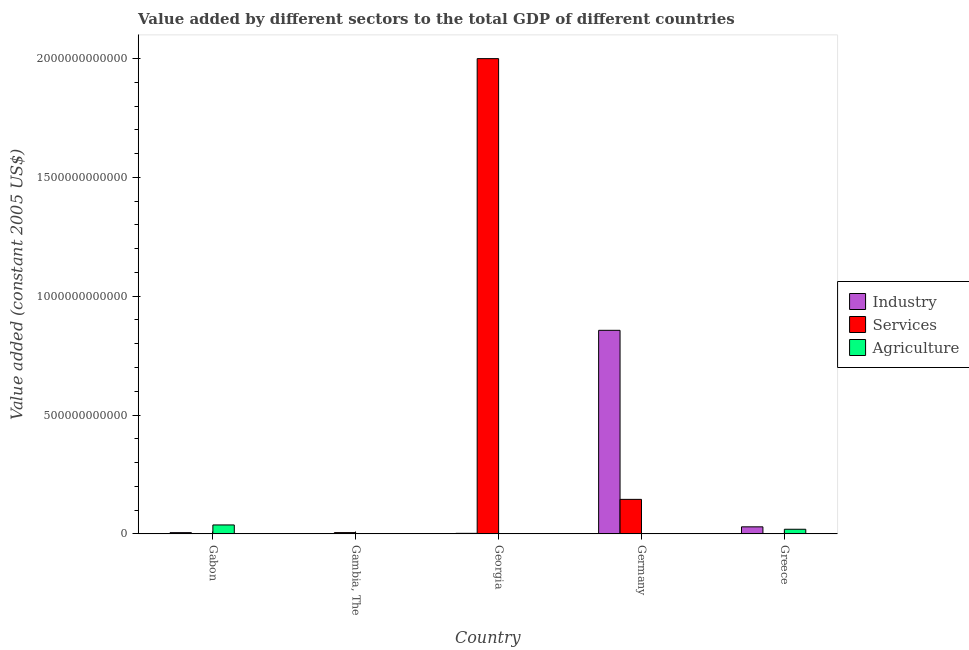How many groups of bars are there?
Your answer should be compact. 5. Are the number of bars per tick equal to the number of legend labels?
Offer a very short reply. Yes. Are the number of bars on each tick of the X-axis equal?
Ensure brevity in your answer.  Yes. How many bars are there on the 5th tick from the left?
Give a very brief answer. 3. What is the label of the 5th group of bars from the left?
Make the answer very short. Greece. In how many cases, is the number of bars for a given country not equal to the number of legend labels?
Give a very brief answer. 0. What is the value added by services in Greece?
Offer a terse response. 4.62e+08. Across all countries, what is the maximum value added by industrial sector?
Your response must be concise. 8.56e+11. Across all countries, what is the minimum value added by services?
Provide a succinct answer. 4.58e+08. In which country was the value added by industrial sector maximum?
Your answer should be compact. Germany. In which country was the value added by industrial sector minimum?
Provide a succinct answer. Gambia, The. What is the total value added by agricultural sector in the graph?
Offer a terse response. 5.84e+1. What is the difference between the value added by industrial sector in Georgia and that in Greece?
Offer a terse response. -2.74e+1. What is the difference between the value added by agricultural sector in Georgia and the value added by services in Greece?
Your response must be concise. -2.84e+08. What is the average value added by industrial sector per country?
Provide a succinct answer. 1.79e+11. What is the difference between the value added by agricultural sector and value added by industrial sector in Gabon?
Give a very brief answer. 3.23e+1. What is the ratio of the value added by agricultural sector in Gabon to that in Greece?
Your response must be concise. 1.94. Is the difference between the value added by industrial sector in Germany and Greece greater than the difference between the value added by agricultural sector in Germany and Greece?
Offer a very short reply. Yes. What is the difference between the highest and the second highest value added by services?
Provide a succinct answer. 1.85e+12. What is the difference between the highest and the lowest value added by agricultural sector?
Keep it short and to the point. 3.73e+1. In how many countries, is the value added by industrial sector greater than the average value added by industrial sector taken over all countries?
Your answer should be very brief. 1. Is the sum of the value added by services in Gambia, The and Greece greater than the maximum value added by agricultural sector across all countries?
Offer a terse response. No. What does the 3rd bar from the left in Gambia, The represents?
Your answer should be very brief. Agriculture. What does the 3rd bar from the right in Gambia, The represents?
Provide a short and direct response. Industry. Is it the case that in every country, the sum of the value added by industrial sector and value added by services is greater than the value added by agricultural sector?
Provide a succinct answer. No. Are all the bars in the graph horizontal?
Keep it short and to the point. No. How many countries are there in the graph?
Provide a succinct answer. 5. What is the difference between two consecutive major ticks on the Y-axis?
Ensure brevity in your answer.  5.00e+11. Where does the legend appear in the graph?
Your response must be concise. Center right. How many legend labels are there?
Offer a terse response. 3. What is the title of the graph?
Make the answer very short. Value added by different sectors to the total GDP of different countries. What is the label or title of the X-axis?
Your answer should be very brief. Country. What is the label or title of the Y-axis?
Offer a very short reply. Value added (constant 2005 US$). What is the Value added (constant 2005 US$) in Industry in Gabon?
Your answer should be compact. 5.19e+09. What is the Value added (constant 2005 US$) of Services in Gabon?
Give a very brief answer. 4.58e+08. What is the Value added (constant 2005 US$) in Agriculture in Gabon?
Your response must be concise. 3.75e+1. What is the Value added (constant 2005 US$) of Industry in Gambia, The?
Your answer should be compact. 1.10e+08. What is the Value added (constant 2005 US$) of Services in Gambia, The?
Your answer should be compact. 5.32e+09. What is the Value added (constant 2005 US$) of Agriculture in Gambia, The?
Make the answer very short. 4.72e+08. What is the Value added (constant 2005 US$) of Industry in Georgia?
Your answer should be compact. 2.22e+09. What is the Value added (constant 2005 US$) in Services in Georgia?
Offer a terse response. 2.00e+12. What is the Value added (constant 2005 US$) in Agriculture in Georgia?
Keep it short and to the point. 1.79e+08. What is the Value added (constant 2005 US$) in Industry in Germany?
Give a very brief answer. 8.56e+11. What is the Value added (constant 2005 US$) in Services in Germany?
Keep it short and to the point. 1.45e+11. What is the Value added (constant 2005 US$) in Agriculture in Germany?
Make the answer very short. 8.41e+08. What is the Value added (constant 2005 US$) of Industry in Greece?
Provide a succinct answer. 2.96e+1. What is the Value added (constant 2005 US$) in Services in Greece?
Your response must be concise. 4.62e+08. What is the Value added (constant 2005 US$) of Agriculture in Greece?
Your answer should be compact. 1.94e+1. Across all countries, what is the maximum Value added (constant 2005 US$) of Industry?
Provide a short and direct response. 8.56e+11. Across all countries, what is the maximum Value added (constant 2005 US$) in Services?
Your response must be concise. 2.00e+12. Across all countries, what is the maximum Value added (constant 2005 US$) in Agriculture?
Keep it short and to the point. 3.75e+1. Across all countries, what is the minimum Value added (constant 2005 US$) of Industry?
Ensure brevity in your answer.  1.10e+08. Across all countries, what is the minimum Value added (constant 2005 US$) of Services?
Your answer should be compact. 4.58e+08. Across all countries, what is the minimum Value added (constant 2005 US$) of Agriculture?
Provide a short and direct response. 1.79e+08. What is the total Value added (constant 2005 US$) in Industry in the graph?
Provide a short and direct response. 8.93e+11. What is the total Value added (constant 2005 US$) in Services in the graph?
Make the answer very short. 2.15e+12. What is the total Value added (constant 2005 US$) in Agriculture in the graph?
Ensure brevity in your answer.  5.84e+1. What is the difference between the Value added (constant 2005 US$) in Industry in Gabon and that in Gambia, The?
Ensure brevity in your answer.  5.08e+09. What is the difference between the Value added (constant 2005 US$) of Services in Gabon and that in Gambia, The?
Offer a very short reply. -4.87e+09. What is the difference between the Value added (constant 2005 US$) in Agriculture in Gabon and that in Gambia, The?
Your answer should be compact. 3.70e+1. What is the difference between the Value added (constant 2005 US$) of Industry in Gabon and that in Georgia?
Offer a terse response. 2.97e+09. What is the difference between the Value added (constant 2005 US$) of Services in Gabon and that in Georgia?
Offer a terse response. -2.00e+12. What is the difference between the Value added (constant 2005 US$) of Agriculture in Gabon and that in Georgia?
Provide a short and direct response. 3.73e+1. What is the difference between the Value added (constant 2005 US$) of Industry in Gabon and that in Germany?
Your answer should be compact. -8.51e+11. What is the difference between the Value added (constant 2005 US$) in Services in Gabon and that in Germany?
Your answer should be very brief. -1.45e+11. What is the difference between the Value added (constant 2005 US$) of Agriculture in Gabon and that in Germany?
Your response must be concise. 3.67e+1. What is the difference between the Value added (constant 2005 US$) in Industry in Gabon and that in Greece?
Your answer should be very brief. -2.44e+1. What is the difference between the Value added (constant 2005 US$) in Services in Gabon and that in Greece?
Offer a very short reply. -4.77e+06. What is the difference between the Value added (constant 2005 US$) of Agriculture in Gabon and that in Greece?
Provide a succinct answer. 1.82e+1. What is the difference between the Value added (constant 2005 US$) in Industry in Gambia, The and that in Georgia?
Make the answer very short. -2.11e+09. What is the difference between the Value added (constant 2005 US$) of Services in Gambia, The and that in Georgia?
Your answer should be very brief. -1.99e+12. What is the difference between the Value added (constant 2005 US$) of Agriculture in Gambia, The and that in Georgia?
Make the answer very short. 2.93e+08. What is the difference between the Value added (constant 2005 US$) of Industry in Gambia, The and that in Germany?
Provide a succinct answer. -8.56e+11. What is the difference between the Value added (constant 2005 US$) in Services in Gambia, The and that in Germany?
Provide a short and direct response. -1.40e+11. What is the difference between the Value added (constant 2005 US$) in Agriculture in Gambia, The and that in Germany?
Give a very brief answer. -3.69e+08. What is the difference between the Value added (constant 2005 US$) in Industry in Gambia, The and that in Greece?
Offer a terse response. -2.95e+1. What is the difference between the Value added (constant 2005 US$) in Services in Gambia, The and that in Greece?
Your response must be concise. 4.86e+09. What is the difference between the Value added (constant 2005 US$) of Agriculture in Gambia, The and that in Greece?
Ensure brevity in your answer.  -1.89e+1. What is the difference between the Value added (constant 2005 US$) of Industry in Georgia and that in Germany?
Offer a very short reply. -8.54e+11. What is the difference between the Value added (constant 2005 US$) in Services in Georgia and that in Germany?
Ensure brevity in your answer.  1.85e+12. What is the difference between the Value added (constant 2005 US$) in Agriculture in Georgia and that in Germany?
Make the answer very short. -6.62e+08. What is the difference between the Value added (constant 2005 US$) in Industry in Georgia and that in Greece?
Your answer should be very brief. -2.74e+1. What is the difference between the Value added (constant 2005 US$) in Services in Georgia and that in Greece?
Your answer should be very brief. 2.00e+12. What is the difference between the Value added (constant 2005 US$) in Agriculture in Georgia and that in Greece?
Make the answer very short. -1.92e+1. What is the difference between the Value added (constant 2005 US$) in Industry in Germany and that in Greece?
Give a very brief answer. 8.27e+11. What is the difference between the Value added (constant 2005 US$) of Services in Germany and that in Greece?
Provide a short and direct response. 1.45e+11. What is the difference between the Value added (constant 2005 US$) of Agriculture in Germany and that in Greece?
Provide a short and direct response. -1.85e+1. What is the difference between the Value added (constant 2005 US$) in Industry in Gabon and the Value added (constant 2005 US$) in Services in Gambia, The?
Offer a terse response. -1.34e+08. What is the difference between the Value added (constant 2005 US$) in Industry in Gabon and the Value added (constant 2005 US$) in Agriculture in Gambia, The?
Provide a short and direct response. 4.72e+09. What is the difference between the Value added (constant 2005 US$) of Services in Gabon and the Value added (constant 2005 US$) of Agriculture in Gambia, The?
Provide a short and direct response. -1.39e+07. What is the difference between the Value added (constant 2005 US$) in Industry in Gabon and the Value added (constant 2005 US$) in Services in Georgia?
Keep it short and to the point. -1.99e+12. What is the difference between the Value added (constant 2005 US$) in Industry in Gabon and the Value added (constant 2005 US$) in Agriculture in Georgia?
Offer a very short reply. 5.01e+09. What is the difference between the Value added (constant 2005 US$) in Services in Gabon and the Value added (constant 2005 US$) in Agriculture in Georgia?
Your answer should be compact. 2.79e+08. What is the difference between the Value added (constant 2005 US$) of Industry in Gabon and the Value added (constant 2005 US$) of Services in Germany?
Your answer should be compact. -1.40e+11. What is the difference between the Value added (constant 2005 US$) of Industry in Gabon and the Value added (constant 2005 US$) of Agriculture in Germany?
Give a very brief answer. 4.35e+09. What is the difference between the Value added (constant 2005 US$) in Services in Gabon and the Value added (constant 2005 US$) in Agriculture in Germany?
Provide a short and direct response. -3.83e+08. What is the difference between the Value added (constant 2005 US$) in Industry in Gabon and the Value added (constant 2005 US$) in Services in Greece?
Your response must be concise. 4.73e+09. What is the difference between the Value added (constant 2005 US$) in Industry in Gabon and the Value added (constant 2005 US$) in Agriculture in Greece?
Offer a very short reply. -1.42e+1. What is the difference between the Value added (constant 2005 US$) in Services in Gabon and the Value added (constant 2005 US$) in Agriculture in Greece?
Provide a short and direct response. -1.89e+1. What is the difference between the Value added (constant 2005 US$) of Industry in Gambia, The and the Value added (constant 2005 US$) of Services in Georgia?
Your response must be concise. -2.00e+12. What is the difference between the Value added (constant 2005 US$) in Industry in Gambia, The and the Value added (constant 2005 US$) in Agriculture in Georgia?
Keep it short and to the point. -6.81e+07. What is the difference between the Value added (constant 2005 US$) in Services in Gambia, The and the Value added (constant 2005 US$) in Agriculture in Georgia?
Offer a very short reply. 5.15e+09. What is the difference between the Value added (constant 2005 US$) of Industry in Gambia, The and the Value added (constant 2005 US$) of Services in Germany?
Offer a terse response. -1.45e+11. What is the difference between the Value added (constant 2005 US$) in Industry in Gambia, The and the Value added (constant 2005 US$) in Agriculture in Germany?
Your answer should be compact. -7.30e+08. What is the difference between the Value added (constant 2005 US$) in Services in Gambia, The and the Value added (constant 2005 US$) in Agriculture in Germany?
Your answer should be compact. 4.48e+09. What is the difference between the Value added (constant 2005 US$) of Industry in Gambia, The and the Value added (constant 2005 US$) of Services in Greece?
Offer a very short reply. -3.52e+08. What is the difference between the Value added (constant 2005 US$) in Industry in Gambia, The and the Value added (constant 2005 US$) in Agriculture in Greece?
Offer a very short reply. -1.92e+1. What is the difference between the Value added (constant 2005 US$) of Services in Gambia, The and the Value added (constant 2005 US$) of Agriculture in Greece?
Offer a terse response. -1.40e+1. What is the difference between the Value added (constant 2005 US$) in Industry in Georgia and the Value added (constant 2005 US$) in Services in Germany?
Offer a very short reply. -1.43e+11. What is the difference between the Value added (constant 2005 US$) in Industry in Georgia and the Value added (constant 2005 US$) in Agriculture in Germany?
Offer a very short reply. 1.38e+09. What is the difference between the Value added (constant 2005 US$) of Services in Georgia and the Value added (constant 2005 US$) of Agriculture in Germany?
Offer a very short reply. 2.00e+12. What is the difference between the Value added (constant 2005 US$) in Industry in Georgia and the Value added (constant 2005 US$) in Services in Greece?
Offer a very short reply. 1.75e+09. What is the difference between the Value added (constant 2005 US$) in Industry in Georgia and the Value added (constant 2005 US$) in Agriculture in Greece?
Make the answer very short. -1.71e+1. What is the difference between the Value added (constant 2005 US$) in Services in Georgia and the Value added (constant 2005 US$) in Agriculture in Greece?
Give a very brief answer. 1.98e+12. What is the difference between the Value added (constant 2005 US$) in Industry in Germany and the Value added (constant 2005 US$) in Services in Greece?
Provide a succinct answer. 8.56e+11. What is the difference between the Value added (constant 2005 US$) in Industry in Germany and the Value added (constant 2005 US$) in Agriculture in Greece?
Provide a short and direct response. 8.37e+11. What is the difference between the Value added (constant 2005 US$) in Services in Germany and the Value added (constant 2005 US$) in Agriculture in Greece?
Your response must be concise. 1.26e+11. What is the average Value added (constant 2005 US$) in Industry per country?
Keep it short and to the point. 1.79e+11. What is the average Value added (constant 2005 US$) in Services per country?
Provide a short and direct response. 4.30e+11. What is the average Value added (constant 2005 US$) in Agriculture per country?
Your answer should be very brief. 1.17e+1. What is the difference between the Value added (constant 2005 US$) of Industry and Value added (constant 2005 US$) of Services in Gabon?
Keep it short and to the point. 4.73e+09. What is the difference between the Value added (constant 2005 US$) in Industry and Value added (constant 2005 US$) in Agriculture in Gabon?
Your answer should be compact. -3.23e+1. What is the difference between the Value added (constant 2005 US$) in Services and Value added (constant 2005 US$) in Agriculture in Gabon?
Keep it short and to the point. -3.71e+1. What is the difference between the Value added (constant 2005 US$) of Industry and Value added (constant 2005 US$) of Services in Gambia, The?
Provide a short and direct response. -5.21e+09. What is the difference between the Value added (constant 2005 US$) in Industry and Value added (constant 2005 US$) in Agriculture in Gambia, The?
Make the answer very short. -3.61e+08. What is the difference between the Value added (constant 2005 US$) in Services and Value added (constant 2005 US$) in Agriculture in Gambia, The?
Offer a terse response. 4.85e+09. What is the difference between the Value added (constant 2005 US$) in Industry and Value added (constant 2005 US$) in Services in Georgia?
Offer a terse response. -2.00e+12. What is the difference between the Value added (constant 2005 US$) of Industry and Value added (constant 2005 US$) of Agriculture in Georgia?
Your answer should be compact. 2.04e+09. What is the difference between the Value added (constant 2005 US$) of Services and Value added (constant 2005 US$) of Agriculture in Georgia?
Keep it short and to the point. 2.00e+12. What is the difference between the Value added (constant 2005 US$) of Industry and Value added (constant 2005 US$) of Services in Germany?
Provide a short and direct response. 7.11e+11. What is the difference between the Value added (constant 2005 US$) of Industry and Value added (constant 2005 US$) of Agriculture in Germany?
Ensure brevity in your answer.  8.56e+11. What is the difference between the Value added (constant 2005 US$) in Services and Value added (constant 2005 US$) in Agriculture in Germany?
Your response must be concise. 1.44e+11. What is the difference between the Value added (constant 2005 US$) in Industry and Value added (constant 2005 US$) in Services in Greece?
Provide a short and direct response. 2.91e+1. What is the difference between the Value added (constant 2005 US$) of Industry and Value added (constant 2005 US$) of Agriculture in Greece?
Keep it short and to the point. 1.02e+1. What is the difference between the Value added (constant 2005 US$) in Services and Value added (constant 2005 US$) in Agriculture in Greece?
Offer a very short reply. -1.89e+1. What is the ratio of the Value added (constant 2005 US$) of Industry in Gabon to that in Gambia, The?
Make the answer very short. 47.01. What is the ratio of the Value added (constant 2005 US$) of Services in Gabon to that in Gambia, The?
Keep it short and to the point. 0.09. What is the ratio of the Value added (constant 2005 US$) of Agriculture in Gabon to that in Gambia, The?
Provide a succinct answer. 79.55. What is the ratio of the Value added (constant 2005 US$) of Industry in Gabon to that in Georgia?
Your answer should be compact. 2.34. What is the ratio of the Value added (constant 2005 US$) of Services in Gabon to that in Georgia?
Your answer should be compact. 0. What is the ratio of the Value added (constant 2005 US$) of Agriculture in Gabon to that in Georgia?
Provide a succinct answer. 210.06. What is the ratio of the Value added (constant 2005 US$) of Industry in Gabon to that in Germany?
Offer a terse response. 0.01. What is the ratio of the Value added (constant 2005 US$) of Services in Gabon to that in Germany?
Your answer should be very brief. 0. What is the ratio of the Value added (constant 2005 US$) in Agriculture in Gabon to that in Germany?
Provide a succinct answer. 44.62. What is the ratio of the Value added (constant 2005 US$) of Industry in Gabon to that in Greece?
Ensure brevity in your answer.  0.18. What is the ratio of the Value added (constant 2005 US$) in Agriculture in Gabon to that in Greece?
Make the answer very short. 1.94. What is the ratio of the Value added (constant 2005 US$) in Industry in Gambia, The to that in Georgia?
Offer a very short reply. 0.05. What is the ratio of the Value added (constant 2005 US$) in Services in Gambia, The to that in Georgia?
Make the answer very short. 0. What is the ratio of the Value added (constant 2005 US$) of Agriculture in Gambia, The to that in Georgia?
Provide a succinct answer. 2.64. What is the ratio of the Value added (constant 2005 US$) in Services in Gambia, The to that in Germany?
Offer a terse response. 0.04. What is the ratio of the Value added (constant 2005 US$) of Agriculture in Gambia, The to that in Germany?
Your answer should be very brief. 0.56. What is the ratio of the Value added (constant 2005 US$) of Industry in Gambia, The to that in Greece?
Your response must be concise. 0. What is the ratio of the Value added (constant 2005 US$) in Services in Gambia, The to that in Greece?
Provide a short and direct response. 11.51. What is the ratio of the Value added (constant 2005 US$) of Agriculture in Gambia, The to that in Greece?
Your response must be concise. 0.02. What is the ratio of the Value added (constant 2005 US$) in Industry in Georgia to that in Germany?
Make the answer very short. 0. What is the ratio of the Value added (constant 2005 US$) in Services in Georgia to that in Germany?
Make the answer very short. 13.78. What is the ratio of the Value added (constant 2005 US$) of Agriculture in Georgia to that in Germany?
Make the answer very short. 0.21. What is the ratio of the Value added (constant 2005 US$) in Industry in Georgia to that in Greece?
Your answer should be compact. 0.07. What is the ratio of the Value added (constant 2005 US$) in Services in Georgia to that in Greece?
Your answer should be compact. 4323.5. What is the ratio of the Value added (constant 2005 US$) of Agriculture in Georgia to that in Greece?
Keep it short and to the point. 0.01. What is the ratio of the Value added (constant 2005 US$) in Industry in Germany to that in Greece?
Ensure brevity in your answer.  28.94. What is the ratio of the Value added (constant 2005 US$) in Services in Germany to that in Greece?
Offer a terse response. 313.81. What is the ratio of the Value added (constant 2005 US$) in Agriculture in Germany to that in Greece?
Provide a short and direct response. 0.04. What is the difference between the highest and the second highest Value added (constant 2005 US$) in Industry?
Provide a short and direct response. 8.27e+11. What is the difference between the highest and the second highest Value added (constant 2005 US$) of Services?
Offer a very short reply. 1.85e+12. What is the difference between the highest and the second highest Value added (constant 2005 US$) in Agriculture?
Offer a very short reply. 1.82e+1. What is the difference between the highest and the lowest Value added (constant 2005 US$) in Industry?
Your response must be concise. 8.56e+11. What is the difference between the highest and the lowest Value added (constant 2005 US$) in Services?
Make the answer very short. 2.00e+12. What is the difference between the highest and the lowest Value added (constant 2005 US$) in Agriculture?
Keep it short and to the point. 3.73e+1. 